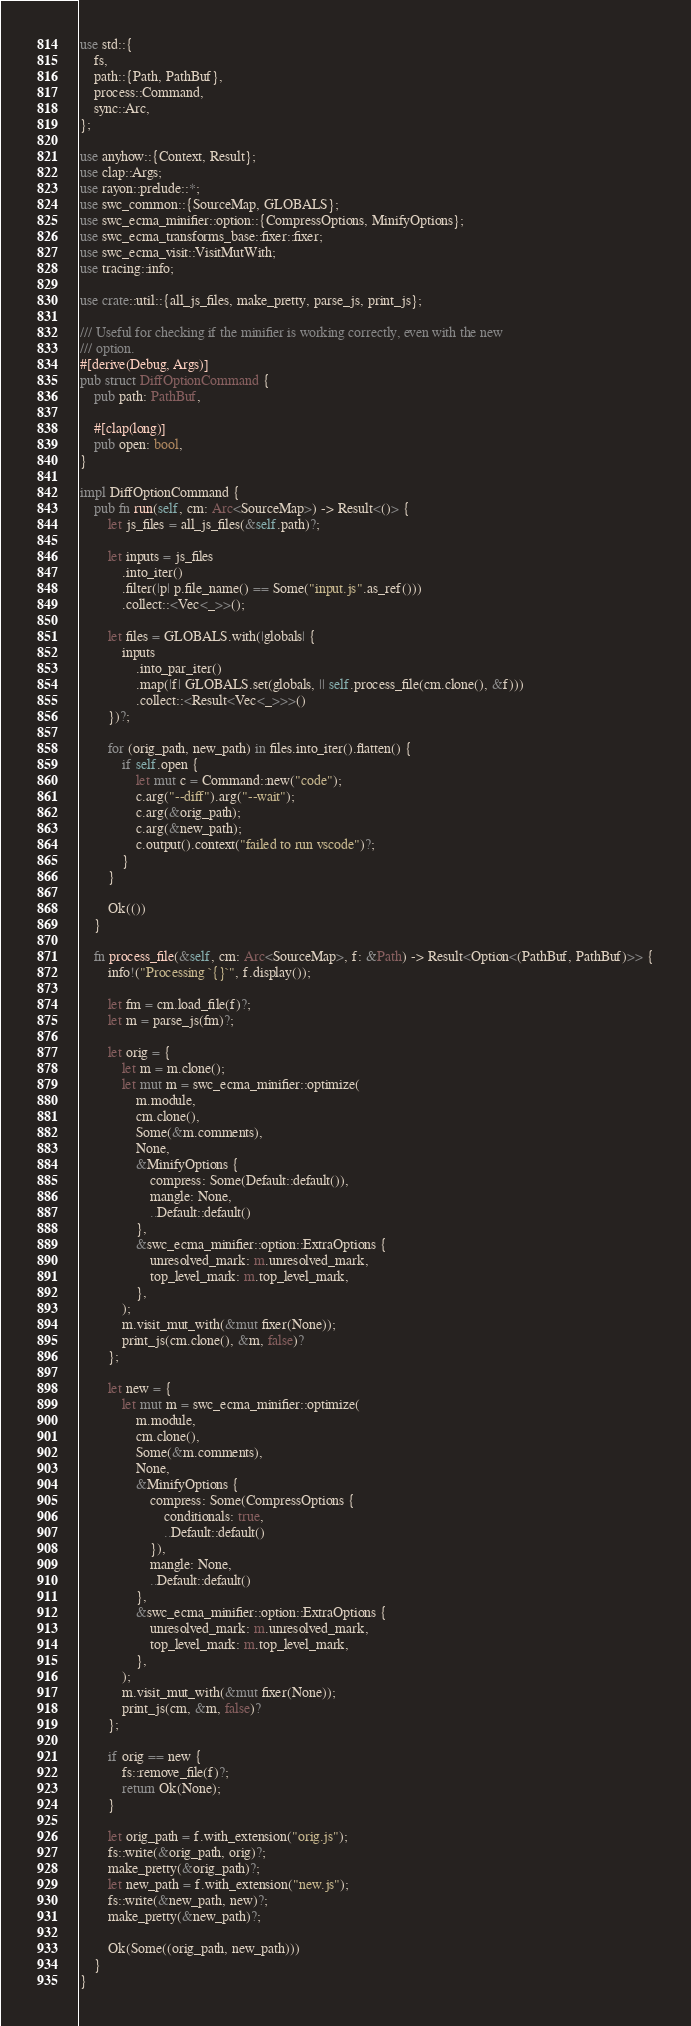<code> <loc_0><loc_0><loc_500><loc_500><_Rust_>use std::{
    fs,
    path::{Path, PathBuf},
    process::Command,
    sync::Arc,
};

use anyhow::{Context, Result};
use clap::Args;
use rayon::prelude::*;
use swc_common::{SourceMap, GLOBALS};
use swc_ecma_minifier::option::{CompressOptions, MinifyOptions};
use swc_ecma_transforms_base::fixer::fixer;
use swc_ecma_visit::VisitMutWith;
use tracing::info;

use crate::util::{all_js_files, make_pretty, parse_js, print_js};

/// Useful for checking if the minifier is working correctly, even with the new
/// option.
#[derive(Debug, Args)]
pub struct DiffOptionCommand {
    pub path: PathBuf,

    #[clap(long)]
    pub open: bool,
}

impl DiffOptionCommand {
    pub fn run(self, cm: Arc<SourceMap>) -> Result<()> {
        let js_files = all_js_files(&self.path)?;

        let inputs = js_files
            .into_iter()
            .filter(|p| p.file_name() == Some("input.js".as_ref()))
            .collect::<Vec<_>>();

        let files = GLOBALS.with(|globals| {
            inputs
                .into_par_iter()
                .map(|f| GLOBALS.set(globals, || self.process_file(cm.clone(), &f)))
                .collect::<Result<Vec<_>>>()
        })?;

        for (orig_path, new_path) in files.into_iter().flatten() {
            if self.open {
                let mut c = Command::new("code");
                c.arg("--diff").arg("--wait");
                c.arg(&orig_path);
                c.arg(&new_path);
                c.output().context("failed to run vscode")?;
            }
        }

        Ok(())
    }

    fn process_file(&self, cm: Arc<SourceMap>, f: &Path) -> Result<Option<(PathBuf, PathBuf)>> {
        info!("Processing `{}`", f.display());

        let fm = cm.load_file(f)?;
        let m = parse_js(fm)?;

        let orig = {
            let m = m.clone();
            let mut m = swc_ecma_minifier::optimize(
                m.module,
                cm.clone(),
                Some(&m.comments),
                None,
                &MinifyOptions {
                    compress: Some(Default::default()),
                    mangle: None,
                    ..Default::default()
                },
                &swc_ecma_minifier::option::ExtraOptions {
                    unresolved_mark: m.unresolved_mark,
                    top_level_mark: m.top_level_mark,
                },
            );
            m.visit_mut_with(&mut fixer(None));
            print_js(cm.clone(), &m, false)?
        };

        let new = {
            let mut m = swc_ecma_minifier::optimize(
                m.module,
                cm.clone(),
                Some(&m.comments),
                None,
                &MinifyOptions {
                    compress: Some(CompressOptions {
                        conditionals: true,
                        ..Default::default()
                    }),
                    mangle: None,
                    ..Default::default()
                },
                &swc_ecma_minifier::option::ExtraOptions {
                    unresolved_mark: m.unresolved_mark,
                    top_level_mark: m.top_level_mark,
                },
            );
            m.visit_mut_with(&mut fixer(None));
            print_js(cm, &m, false)?
        };

        if orig == new {
            fs::remove_file(f)?;
            return Ok(None);
        }

        let orig_path = f.with_extension("orig.js");
        fs::write(&orig_path, orig)?;
        make_pretty(&orig_path)?;
        let new_path = f.with_extension("new.js");
        fs::write(&new_path, new)?;
        make_pretty(&new_path)?;

        Ok(Some((orig_path, new_path)))
    }
}
</code> 